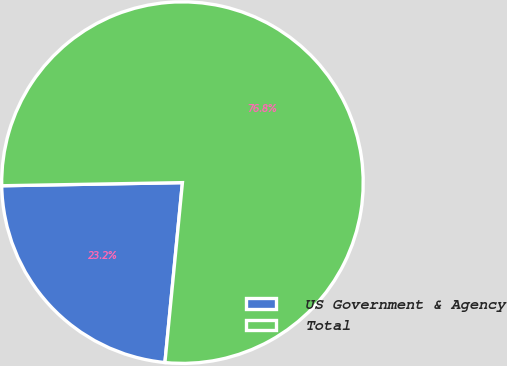Convert chart to OTSL. <chart><loc_0><loc_0><loc_500><loc_500><pie_chart><fcel>US Government & Agency<fcel>Total<nl><fcel>23.18%<fcel>76.82%<nl></chart> 